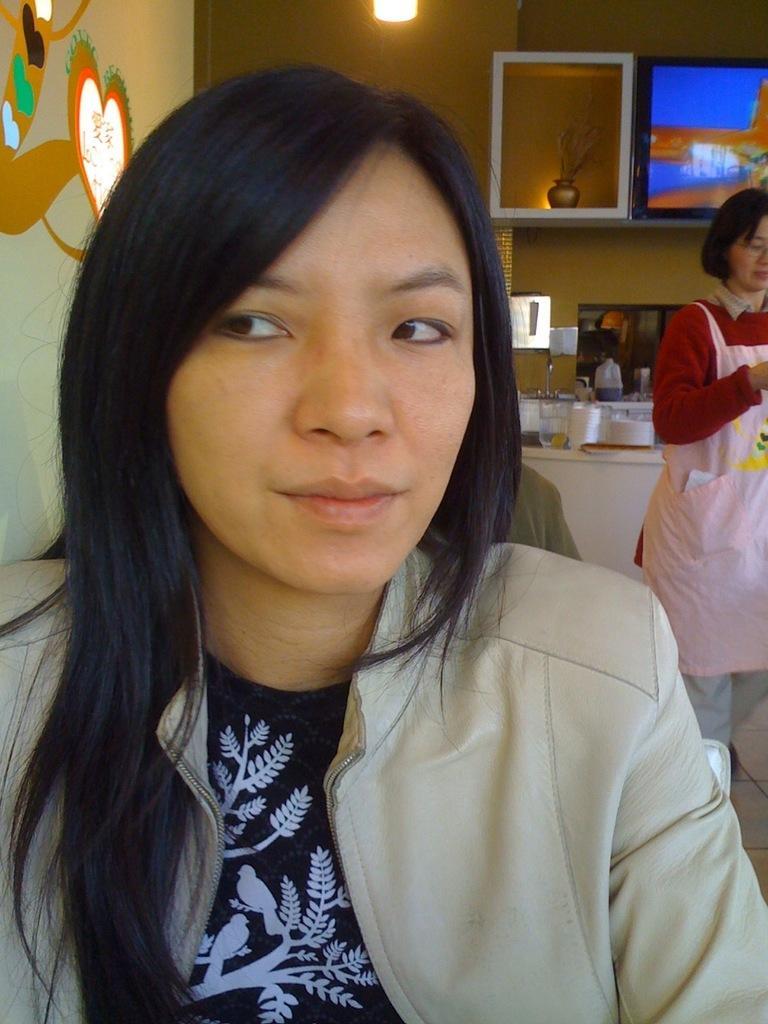Please provide a concise description of this image. Here we can see a woman and there is a person. In the background we can see a cupboard, screen, lights, wall, and objects. 